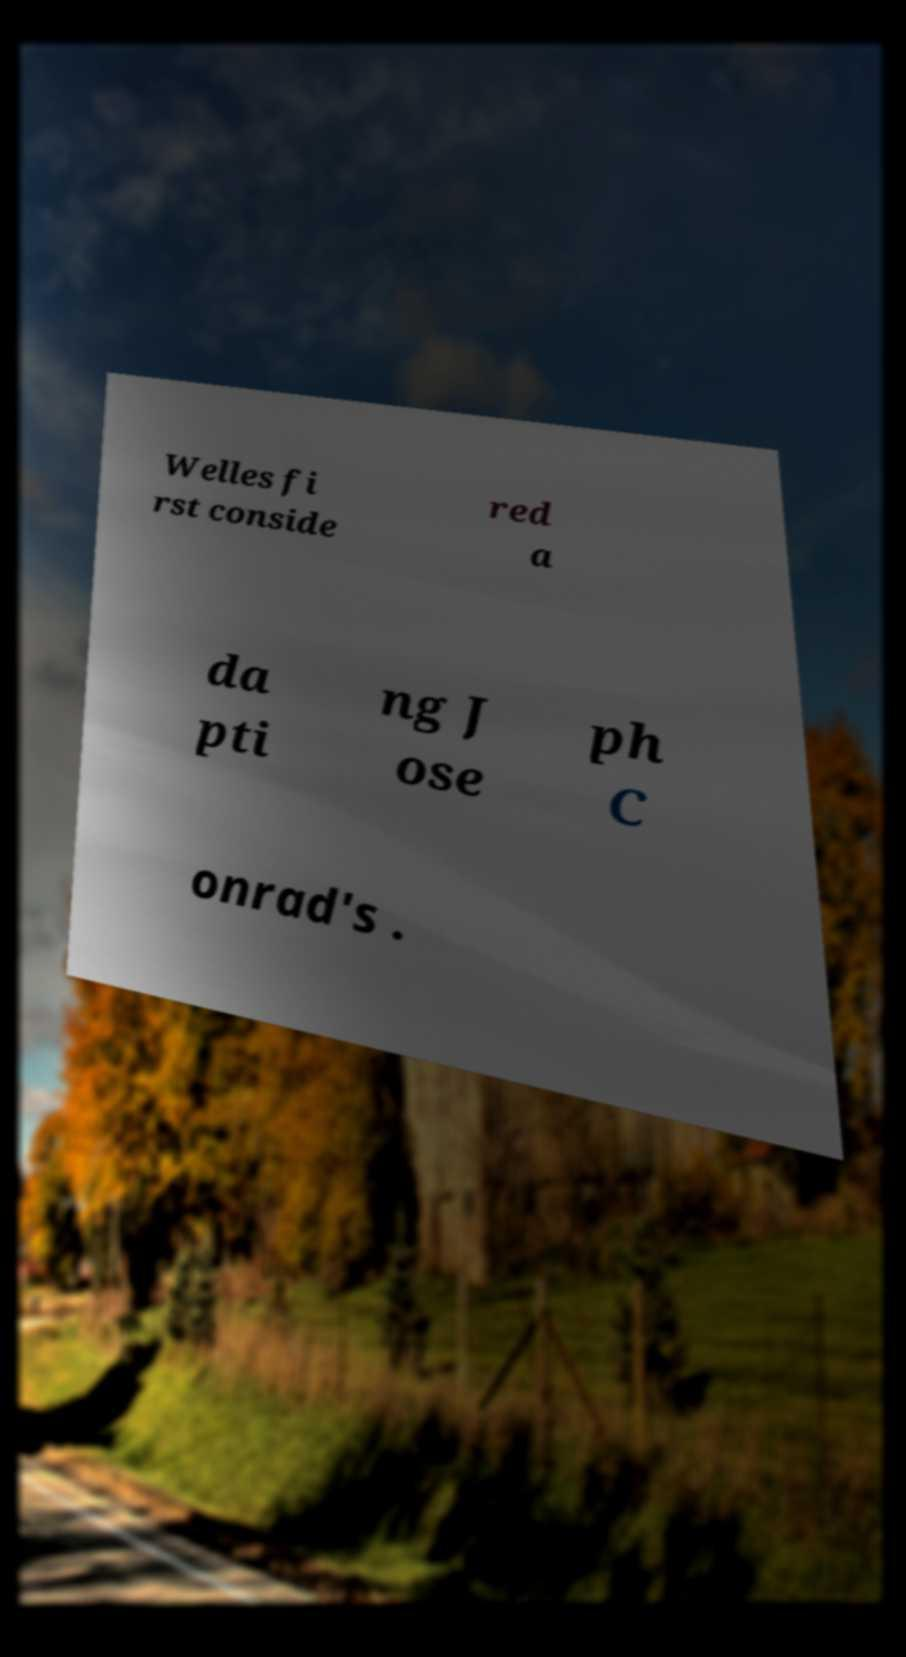Please identify and transcribe the text found in this image. Welles fi rst conside red a da pti ng J ose ph C onrad's . 